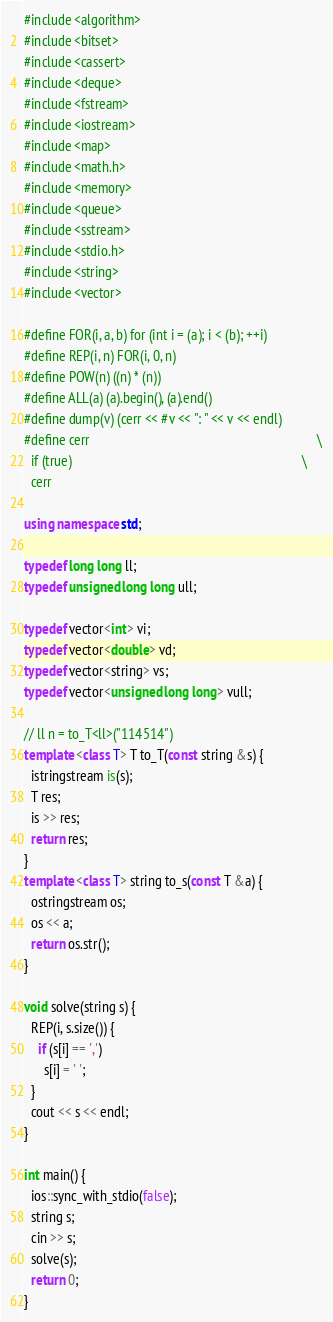<code> <loc_0><loc_0><loc_500><loc_500><_C++_>#include <algorithm>
#include <bitset>
#include <cassert>
#include <deque>
#include <fstream>
#include <iostream>
#include <map>
#include <math.h>
#include <memory>
#include <queue>
#include <sstream>
#include <stdio.h>
#include <string>
#include <vector>

#define FOR(i, a, b) for (int i = (a); i < (b); ++i)
#define REP(i, n) FOR(i, 0, n)
#define POW(n) ((n) * (n))
#define ALL(a) (a).begin(), (a).end()
#define dump(v) (cerr << #v << ": " << v << endl)
#define cerr                                                                   \
  if (true)                                                                    \
  cerr

using namespace std;

typedef long long ll;
typedef unsigned long long ull;

typedef vector<int> vi;
typedef vector<double> vd;
typedef vector<string> vs;
typedef vector<unsigned long long> vull;

// ll n = to_T<ll>("114514")
template <class T> T to_T(const string &s) {
  istringstream is(s);
  T res;
  is >> res;
  return res;
}
template <class T> string to_s(const T &a) {
  ostringstream os;
  os << a;
  return os.str();
}

void solve(string s) {
  REP(i, s.size()) {
    if (s[i] == ',')
      s[i] = ' ';
  }
  cout << s << endl;
}

int main() {
  ios::sync_with_stdio(false);
  string s;
  cin >> s;
  solve(s);
  return 0;
}
</code> 